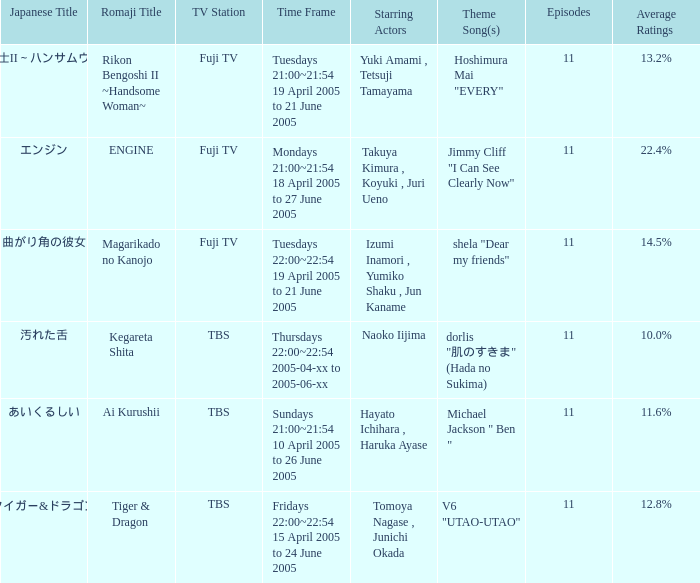Who is the leading actor of the series on thursdays 22:00~22:54 between 2005-04-xx and 2005-06-xx? Naoko Iijima. Can you parse all the data within this table? {'header': ['Japanese Title', 'Romaji Title', 'TV Station', 'Time Frame', 'Starring Actors', 'Theme Song(s)', 'Episodes', 'Average Ratings'], 'rows': [['離婚弁護士II～ハンサムウーマン～', 'Rikon Bengoshi II ~Handsome Woman~', 'Fuji TV', 'Tuesdays 21:00~21:54 19 April 2005 to 21 June 2005', 'Yuki Amami , Tetsuji Tamayama', 'Hoshimura Mai "EVERY"', '11', '13.2%'], ['エンジン', 'ENGINE', 'Fuji TV', 'Mondays 21:00~21:54 18 April 2005 to 27 June 2005', 'Takuya Kimura , Koyuki , Juri Ueno', 'Jimmy Cliff "I Can See Clearly Now"', '11', '22.4%'], ['曲がり角の彼女', 'Magarikado no Kanojo', 'Fuji TV', 'Tuesdays 22:00~22:54 19 April 2005 to 21 June 2005', 'Izumi Inamori , Yumiko Shaku , Jun Kaname', 'shela "Dear my friends"', '11', '14.5%'], ['汚れた舌', 'Kegareta Shita', 'TBS', 'Thursdays 22:00~22:54 2005-04-xx to 2005-06-xx', 'Naoko Iijima', 'dorlis "肌のすきま" (Hada no Sukima)', '11', '10.0%'], ['あいくるしい', 'Ai Kurushii', 'TBS', 'Sundays 21:00~21:54 10 April 2005 to 26 June 2005', 'Hayato Ichihara , Haruka Ayase', 'Michael Jackson " Ben "', '11', '11.6%'], ['タイガー&ドラゴン', 'Tiger & Dragon', 'TBS', 'Fridays 22:00~22:54 15 April 2005 to 24 June 2005', 'Tomoya Nagase , Junichi Okada', 'V6 "UTAO-UTAO"', '11', '12.8%']]} 